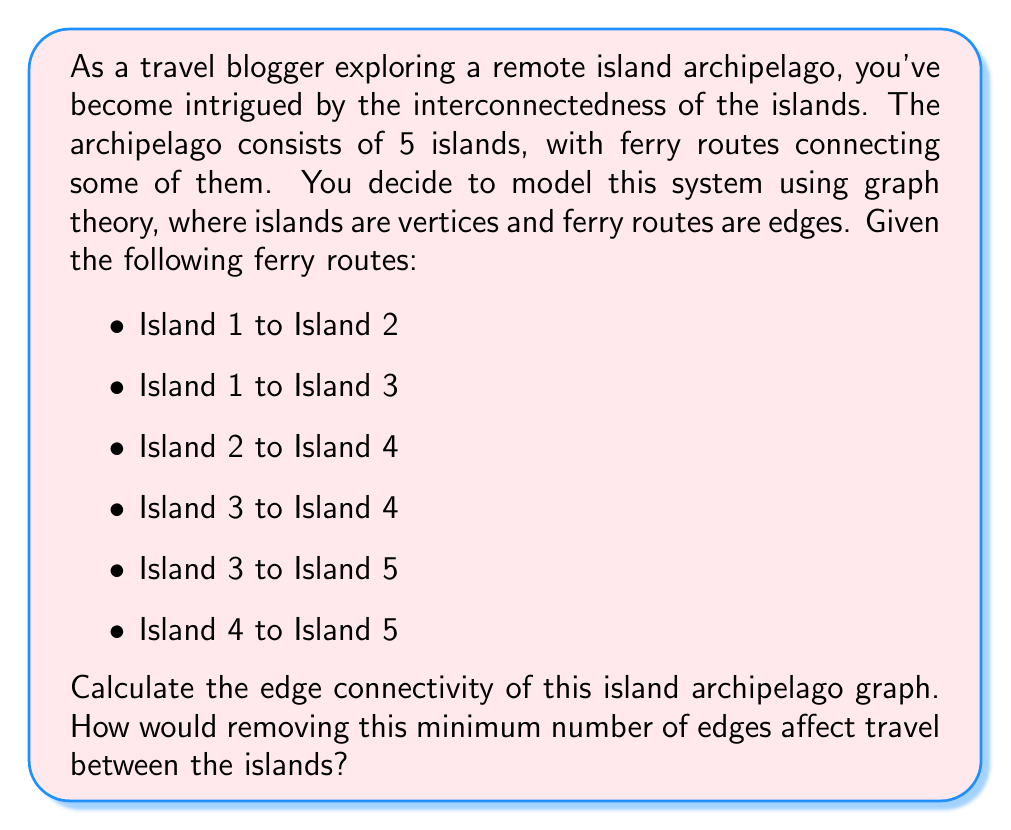Show me your answer to this math problem. To solve this problem, we'll use concepts from graph theory:

1. First, let's visualize the graph:

[asy]
unitsize(1cm);

pair[] vertices = {(0,0), (2,2), (-2,2), (4,0), (-4,0)};
for(int i=0; i<5; ++i) {
    dot(vertices[i]);
    label("I" + string(i+1), vertices[i], align=E);
}

draw(vertices[0]--vertices[1]);
draw(vertices[0]--vertices[2]);
draw(vertices[1]--vertices[3]);
draw(vertices[2]--vertices[3]);
draw(vertices[2]--vertices[4]);
draw(vertices[3]--vertices[4]);
[/asy]

2. Edge connectivity is defined as the minimum number of edges that need to be removed to disconnect the graph.

3. To find the edge connectivity, we need to identify the minimum cut set - the smallest set of edges whose removal would disconnect the graph.

4. By inspection, we can see that removing the edges (I1-I2) and (I1-I3) would isolate Island 1 from the rest of the archipelago. This is a cut set of size 2.

5. To prove this is the minimum cut set, we need to check that there's no single edge whose removal would disconnect the graph. Indeed, for any single edge removed, there's always an alternative path between all pairs of islands.

6. Therefore, the edge connectivity of this graph is 2.

7. Removing these two edges would mean that Island 1 becomes completely isolated. Travelers would no longer be able to reach or leave Island 1 using the ferry system. The other four islands would remain connected to each other.
Answer: The edge connectivity of the island archipelago graph is 2. Removing this minimum number of edges (the ferry routes from Island 1 to Island 2 and Island 1 to Island 3) would isolate Island 1, preventing travel between it and the rest of the archipelago. 